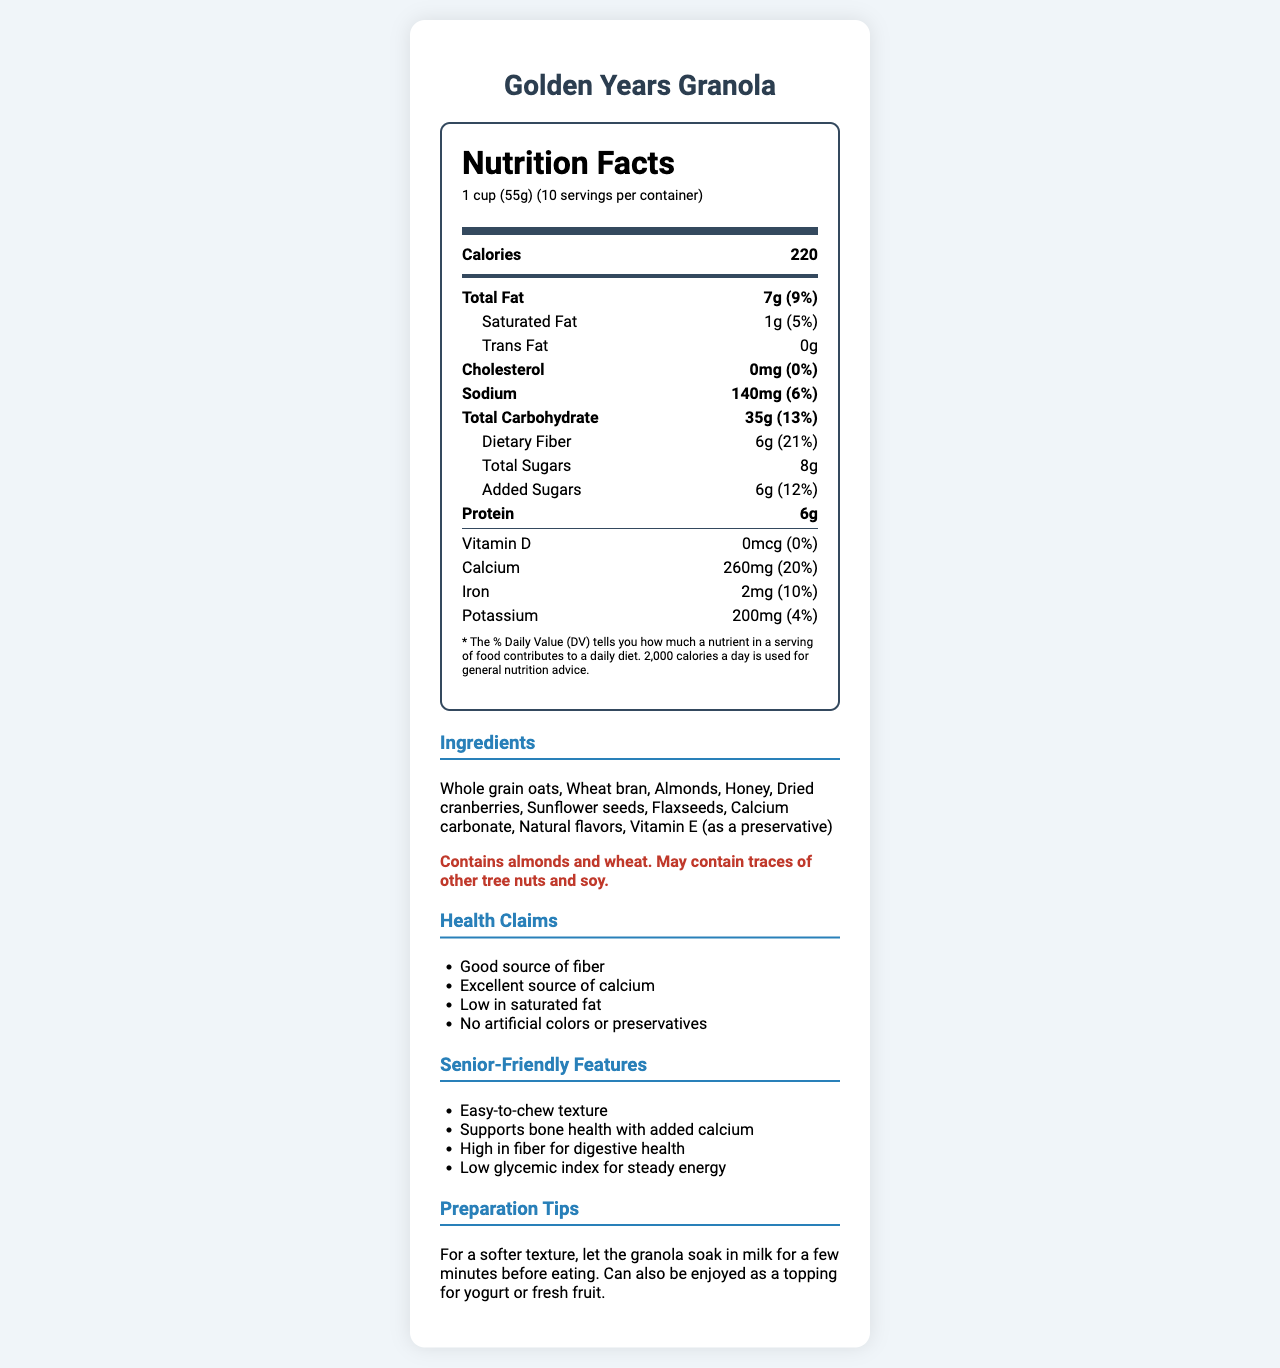what is the serving size of Golden Years Granola? The serving size is indicated at the top of the Nutrition Facts label as "1 cup (55g)".
Answer: 1 cup (55g) how many calories are in one serving? The calories per serving are shown in bold at the top part of the Nutrition Facts label, which indicates 220 calories.
Answer: 220 what is the total amount of dietary fiber per serving? The dietary fiber content is listed under the Total Carbohydrate section, which specifies 6g.
Answer: 6g what percentage of the daily value of calcium is in one serving? Under the Vitamins section of the Nutrition Facts label, it notes that calcium is 20% of the daily value.
Answer: 20% how much added sugar is in one serving of the granola? The added sugars amount is specifically mentioned under the total sugars as 6g.
Answer: 6g which ingredient is used as a source of calcium in the granola? The ingredient list specifies "Calcium carbonate" among the ingredients.
Answer: Calcium carbonate True or False: Golden Years Granola contains Vitamin D. The Nutrition Facts label shows 0mcg for Vitamin D, indicating that it contains none.
Answer: False which of the following health claims is not mentioned on the document? A. Good source of fiber B. Supports heart health C. No artificial colors or preservatives D. Low in saturated fat The health claims listed do not include "Supports heart health". The claims are good source of fiber, excellent source of calcium, low in saturated fat, and no artificial colors or preservatives.
Answer: B how is the granola recommended to be prepared for a softer texture? A. Eat immediately after soaking B. Let it soak in milk for a few minutes C. Heat it in the microwave for 10 seconds D. Add it directly to yogurt It is recommended to let the granola soak in milk for a few minutes before consuming for a softer texture.
Answer: B does one serving of Golden Years Granola contribute to potassium intake? The Nutrition Facts label indicates that one serving contains 200mg of potassium, which is 4% of the daily value.
Answer: Yes can this granola be considered low in sodium? According to the Nutrition Facts, one serving contains 140mg of sodium, which accounts for 6% of the daily value. Typically, 5% DV or less per serving is considered low.
Answer: No is this product suitable for someone with a nut allergy? The allergen information clearly states that it contains almonds and wheat and may contain traces of other tree nuts and soy, which indicates potential risks for someone with a nut allergy.
Answer: No summarize the main features of the Golden Years Granola based on the document. This summary encapsulates the key attributes, nutritional values, ingredients, health claims, and preparation suggestions featured in the document.
Answer: The Golden Years Granola is a nutritious, senior-friendly cereal. It offers 220 calories per serving, is high in fiber (6g) and calcium (260mg), and contains 7g of total fat, 140mg of sodium, and 6g of protein. The ingredients include whole grain oats, almonds, honey, and flaxseeds, among others. It is low in saturated fat, free of artificial colors and preservatives, and designed for easy consumption by seniors. Preparation tips include soaking in milk for a softer texture. what are the health benefits of Vitamin E in the granola? The document mentions Vitamin E as a preservative, but it does not provide specific health benefits or details on its nutritional effect.
Answer: Cannot be determined 